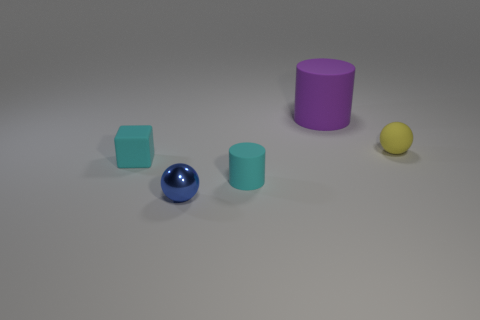Add 1 large balls. How many objects exist? 6 Subtract all cylinders. How many objects are left? 3 Add 2 tiny yellow blocks. How many tiny yellow blocks exist? 2 Subtract 1 cyan cylinders. How many objects are left? 4 Subtract all small yellow objects. Subtract all large purple cylinders. How many objects are left? 3 Add 1 cyan rubber cylinders. How many cyan rubber cylinders are left? 2 